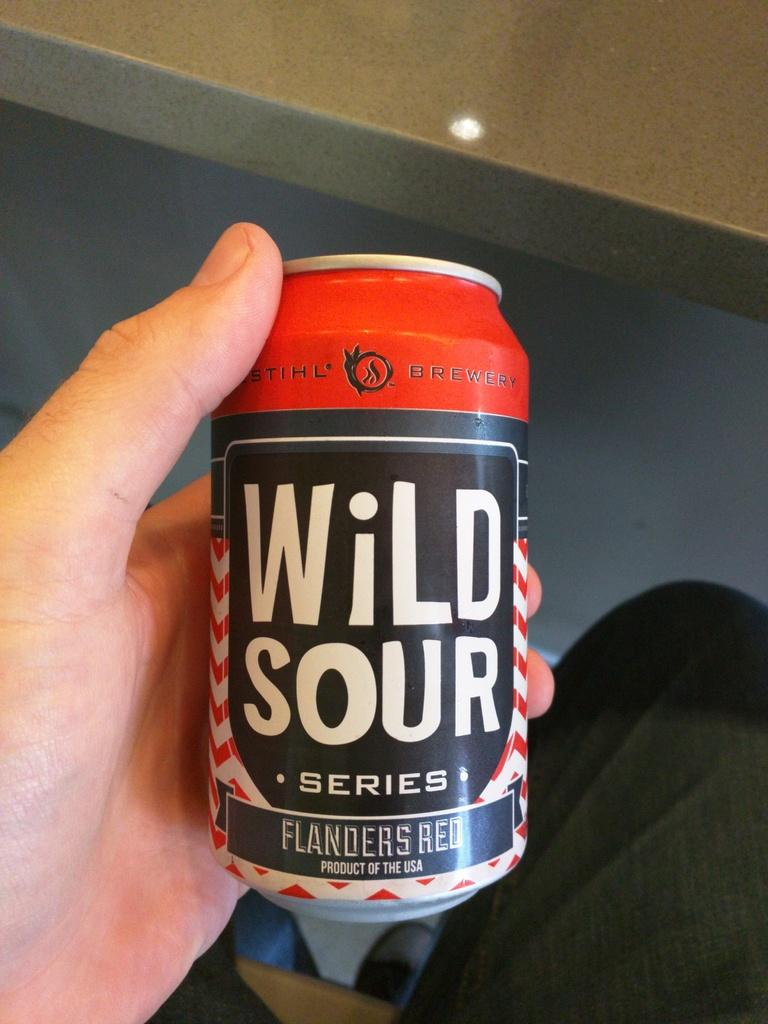<image>
Create a compact narrative representing the image presented. A can has the brand name Wild Sour on it in white lettering. 